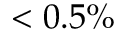<formula> <loc_0><loc_0><loc_500><loc_500>< 0 . 5 \%</formula> 